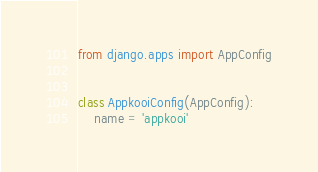<code> <loc_0><loc_0><loc_500><loc_500><_Python_>from django.apps import AppConfig


class AppkooiConfig(AppConfig):
    name = 'appkooi'
</code> 